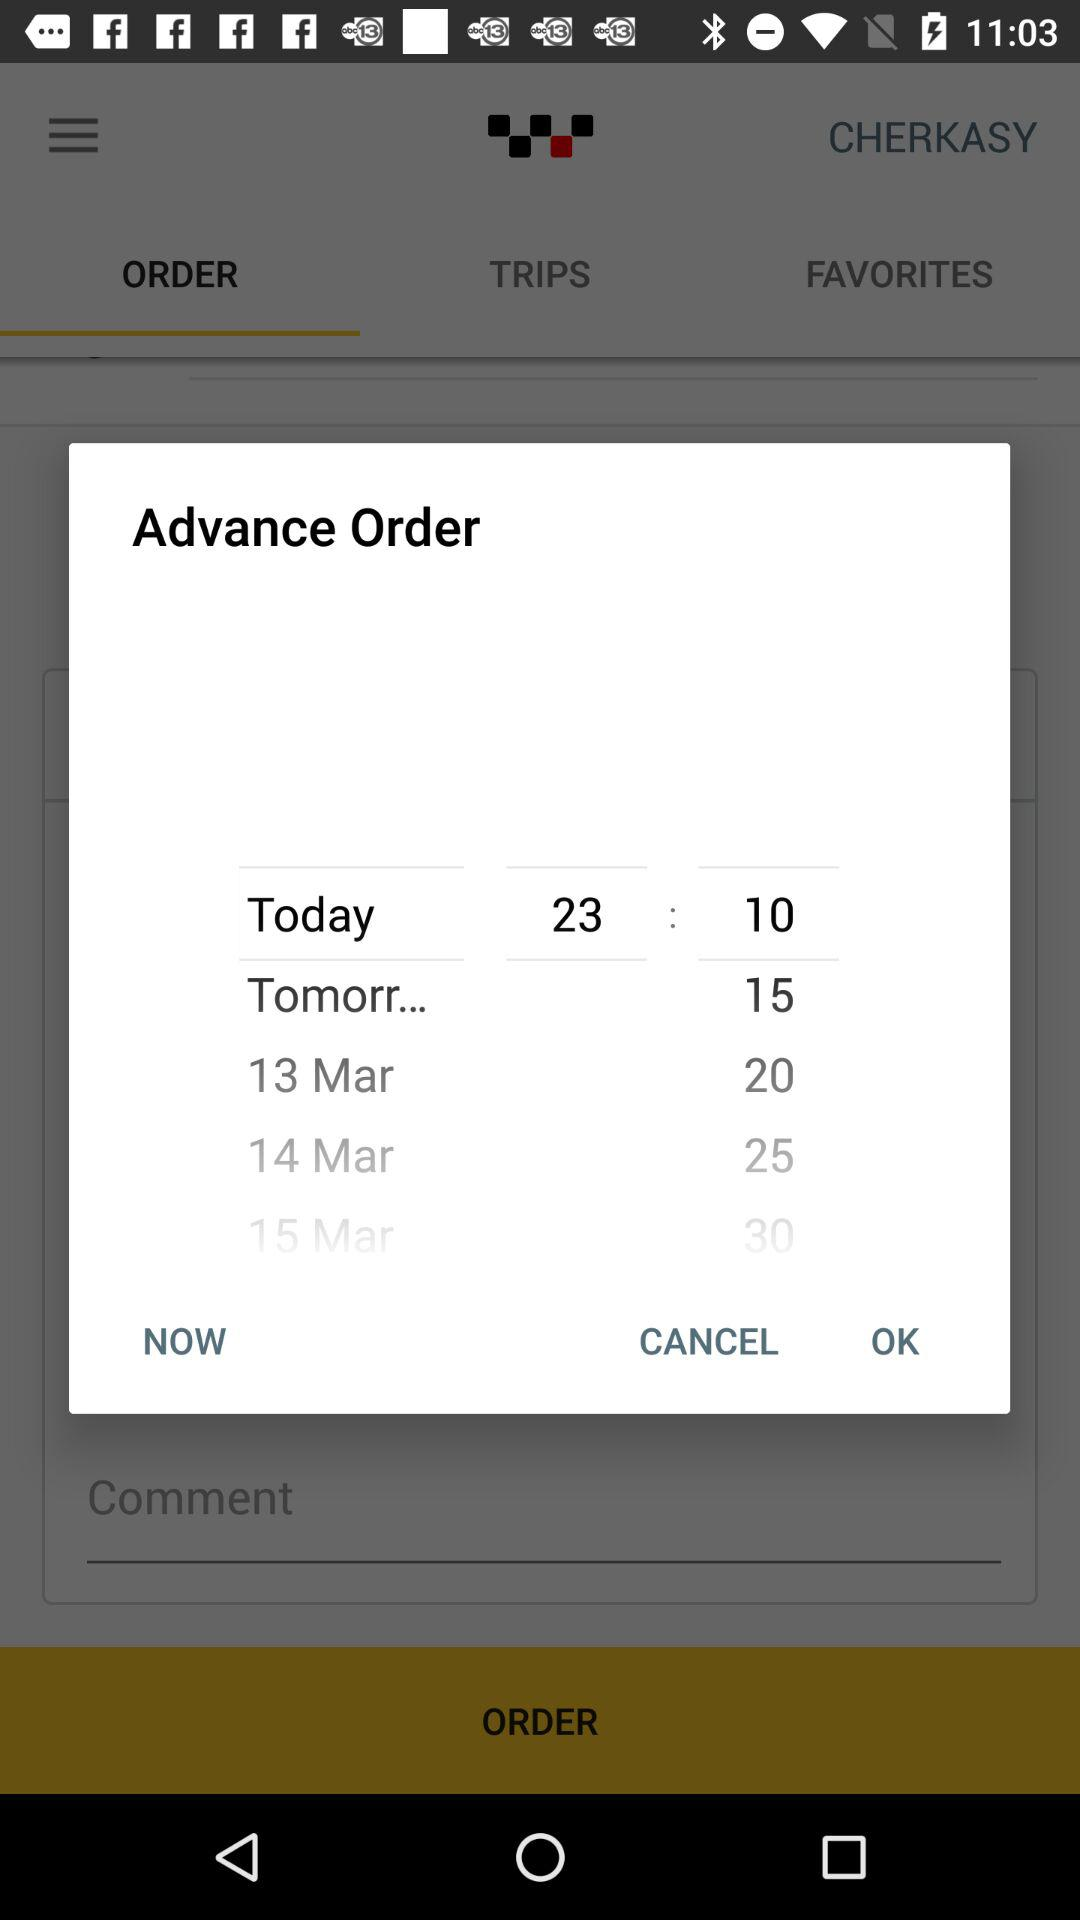Who is placing the advance order?
When the provided information is insufficient, respond with <no answer>. <no answer> 